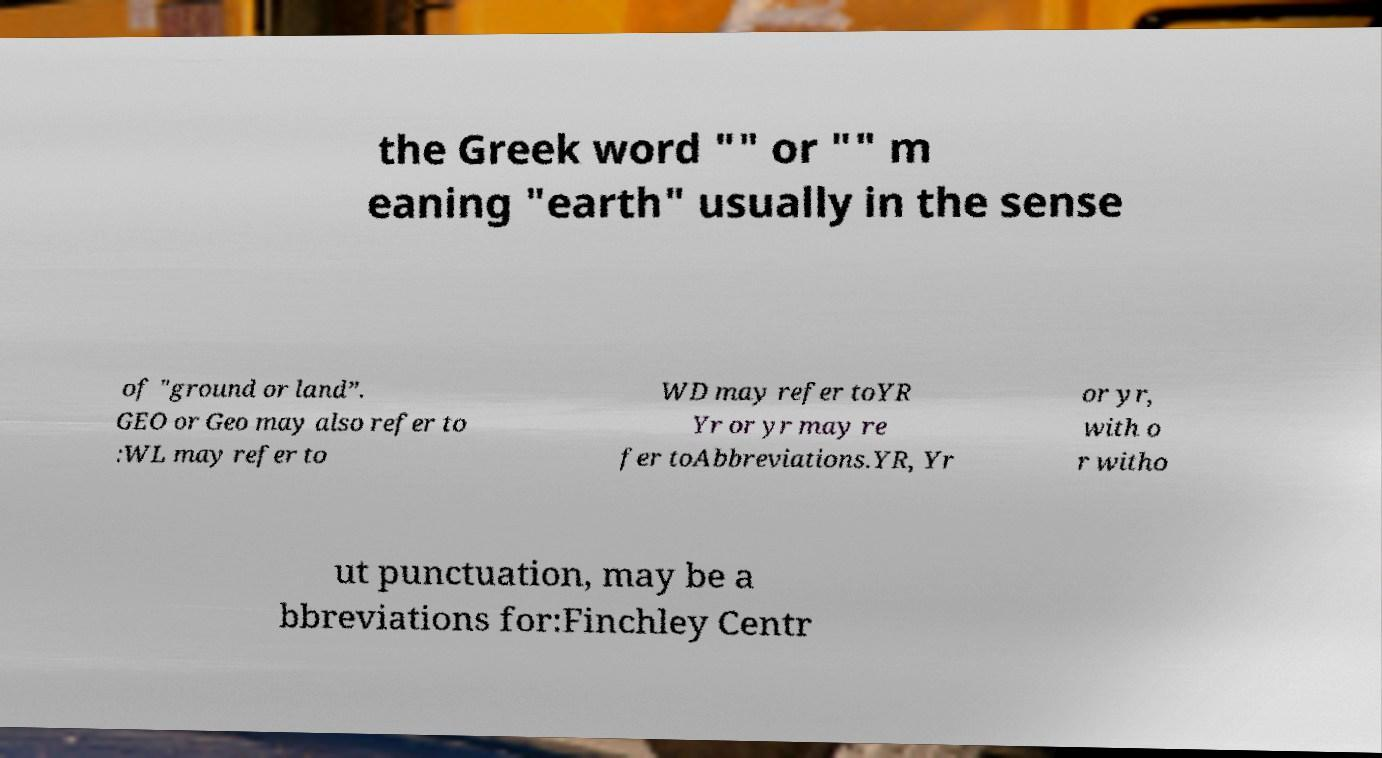I need the written content from this picture converted into text. Can you do that? the Greek word "" or "" m eaning "earth" usually in the sense of "ground or land”. GEO or Geo may also refer to :WL may refer to WD may refer toYR Yr or yr may re fer toAbbreviations.YR, Yr or yr, with o r witho ut punctuation, may be a bbreviations for:Finchley Centr 